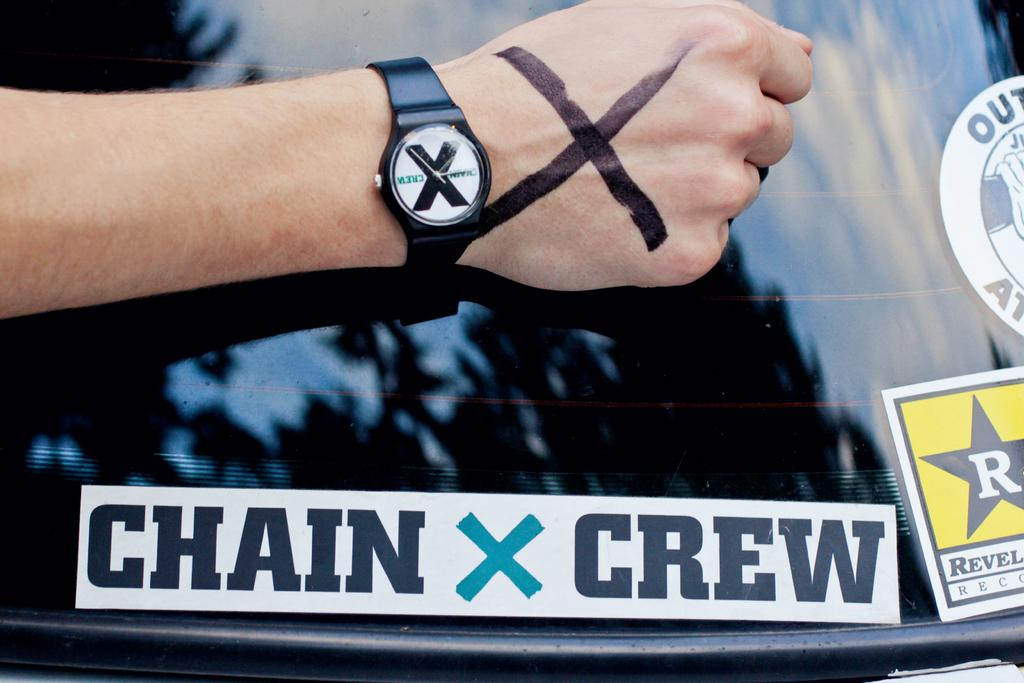<image>
Provide a brief description of the given image. A back windsheild of a car that has a CHAIN X CREW sticker on it. 